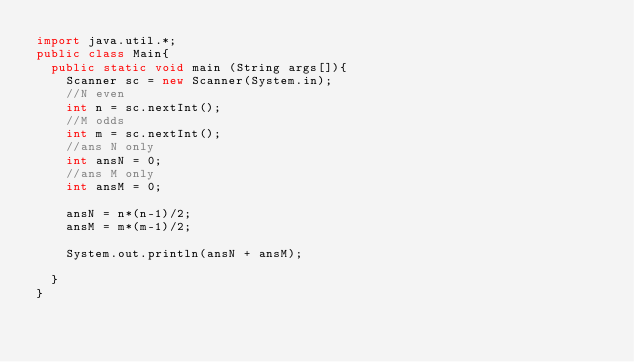<code> <loc_0><loc_0><loc_500><loc_500><_Java_>import java.util.*;
public class Main{
  public static void main (String args[]){
    Scanner sc = new Scanner(System.in);
    //N even
    int n = sc.nextInt();
    //M odds
    int m = sc.nextInt();
    //ans N only
    int ansN = 0;
    //ans M only
    int ansM = 0;
    
    ansN = n*(n-1)/2;
    ansM = m*(m-1)/2;      

    System.out.println(ansN + ansM);
    
  }
}</code> 